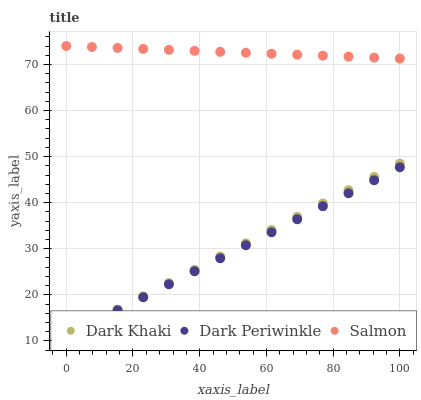Does Dark Periwinkle have the minimum area under the curve?
Answer yes or no. Yes. Does Salmon have the maximum area under the curve?
Answer yes or no. Yes. Does Salmon have the minimum area under the curve?
Answer yes or no. No. Does Dark Periwinkle have the maximum area under the curve?
Answer yes or no. No. Is Dark Periwinkle the smoothest?
Answer yes or no. Yes. Is Salmon the roughest?
Answer yes or no. Yes. Is Salmon the smoothest?
Answer yes or no. No. Is Dark Periwinkle the roughest?
Answer yes or no. No. Does Dark Khaki have the lowest value?
Answer yes or no. Yes. Does Salmon have the lowest value?
Answer yes or no. No. Does Salmon have the highest value?
Answer yes or no. Yes. Does Dark Periwinkle have the highest value?
Answer yes or no. No. Is Dark Khaki less than Salmon?
Answer yes or no. Yes. Is Salmon greater than Dark Periwinkle?
Answer yes or no. Yes. Does Dark Khaki intersect Dark Periwinkle?
Answer yes or no. Yes. Is Dark Khaki less than Dark Periwinkle?
Answer yes or no. No. Is Dark Khaki greater than Dark Periwinkle?
Answer yes or no. No. Does Dark Khaki intersect Salmon?
Answer yes or no. No. 